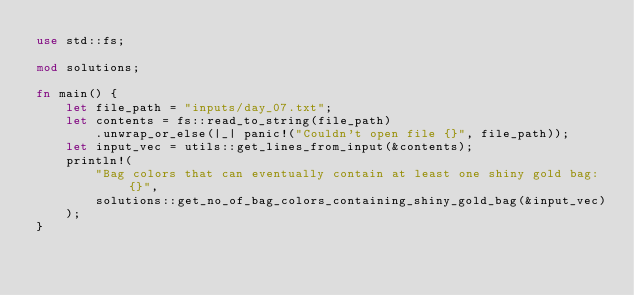Convert code to text. <code><loc_0><loc_0><loc_500><loc_500><_Rust_>use std::fs;

mod solutions;

fn main() {
    let file_path = "inputs/day_07.txt";
    let contents = fs::read_to_string(file_path)
        .unwrap_or_else(|_| panic!("Couldn't open file {}", file_path));
    let input_vec = utils::get_lines_from_input(&contents);
    println!(
        "Bag colors that can eventually contain at least one shiny gold bag: {}",
        solutions::get_no_of_bag_colors_containing_shiny_gold_bag(&input_vec)
    );
}
</code> 